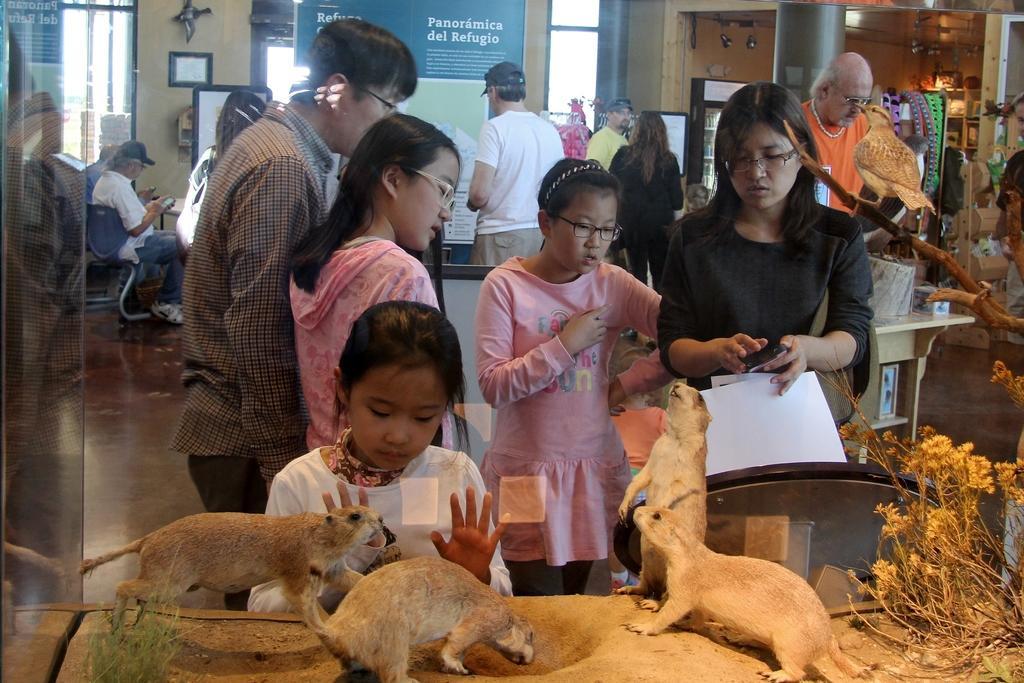In one or two sentences, can you explain what this image depicts? In this picture I can see animals, plants, bird on the branch in a glass box. I can see group of people standing and two persons sitting on the chairs. There are boards, lights, tables, windows and some other objects. 